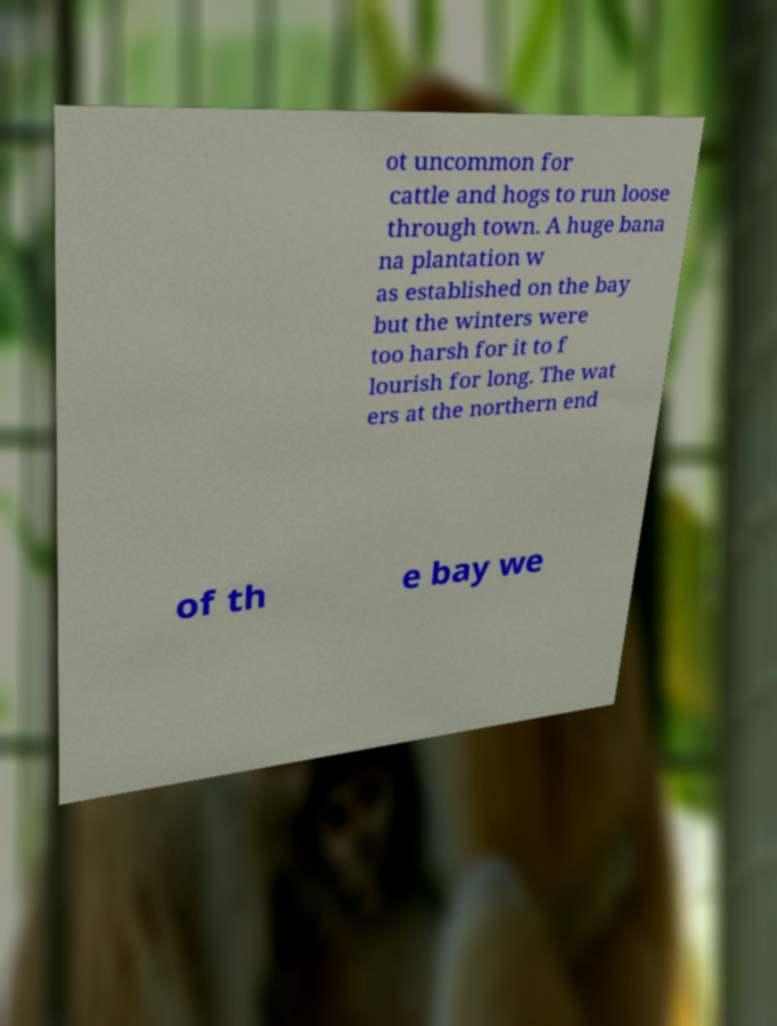For documentation purposes, I need the text within this image transcribed. Could you provide that? ot uncommon for cattle and hogs to run loose through town. A huge bana na plantation w as established on the bay but the winters were too harsh for it to f lourish for long. The wat ers at the northern end of th e bay we 